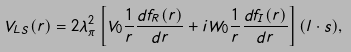Convert formula to latex. <formula><loc_0><loc_0><loc_500><loc_500>V _ { L S } ( r ) = 2 \lambda _ { \pi } ^ { 2 } \left [ V _ { 0 } \frac { 1 } { r } \frac { d f _ { R } ( r ) } { d r } + i W _ { 0 } \frac { 1 } { r } \frac { d f _ { I } ( r ) } { d r } \right ] ( { l } \cdot { s } ) ,</formula> 